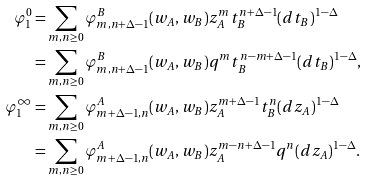Convert formula to latex. <formula><loc_0><loc_0><loc_500><loc_500>\varphi _ { 1 } ^ { 0 } = & \sum _ { m , n \geq 0 } \varphi _ { m , n + \Delta - 1 } ^ { B } ( w _ { A } , w _ { B } ) z _ { A } ^ { m } t _ { B } ^ { n + \Delta - 1 } ( d t _ { B } ) ^ { 1 - \Delta } \\ = & \sum _ { m , n \geq 0 } \varphi _ { m , n + \Delta - 1 } ^ { B } ( w _ { A } , w _ { B } ) q ^ { m } t _ { B } ^ { n - m + \Delta - 1 } ( d t _ { B } ) ^ { 1 - \Delta } , \\ \varphi _ { 1 } ^ { \infty } = & \sum _ { m , n \geq 0 } \varphi _ { m + \Delta - 1 , n } ^ { A } ( w _ { A } , w _ { B } ) z _ { A } ^ { m + \Delta - 1 } t _ { B } ^ { n } ( d z _ { A } ) ^ { 1 - \Delta } \\ = & \sum _ { m , n \geq 0 } \varphi _ { m + \Delta - 1 , n } ^ { A } ( w _ { A } , w _ { B } ) z _ { A } ^ { m - n + \Delta - 1 } q ^ { n } ( d z _ { A } ) ^ { 1 - \Delta } .</formula> 